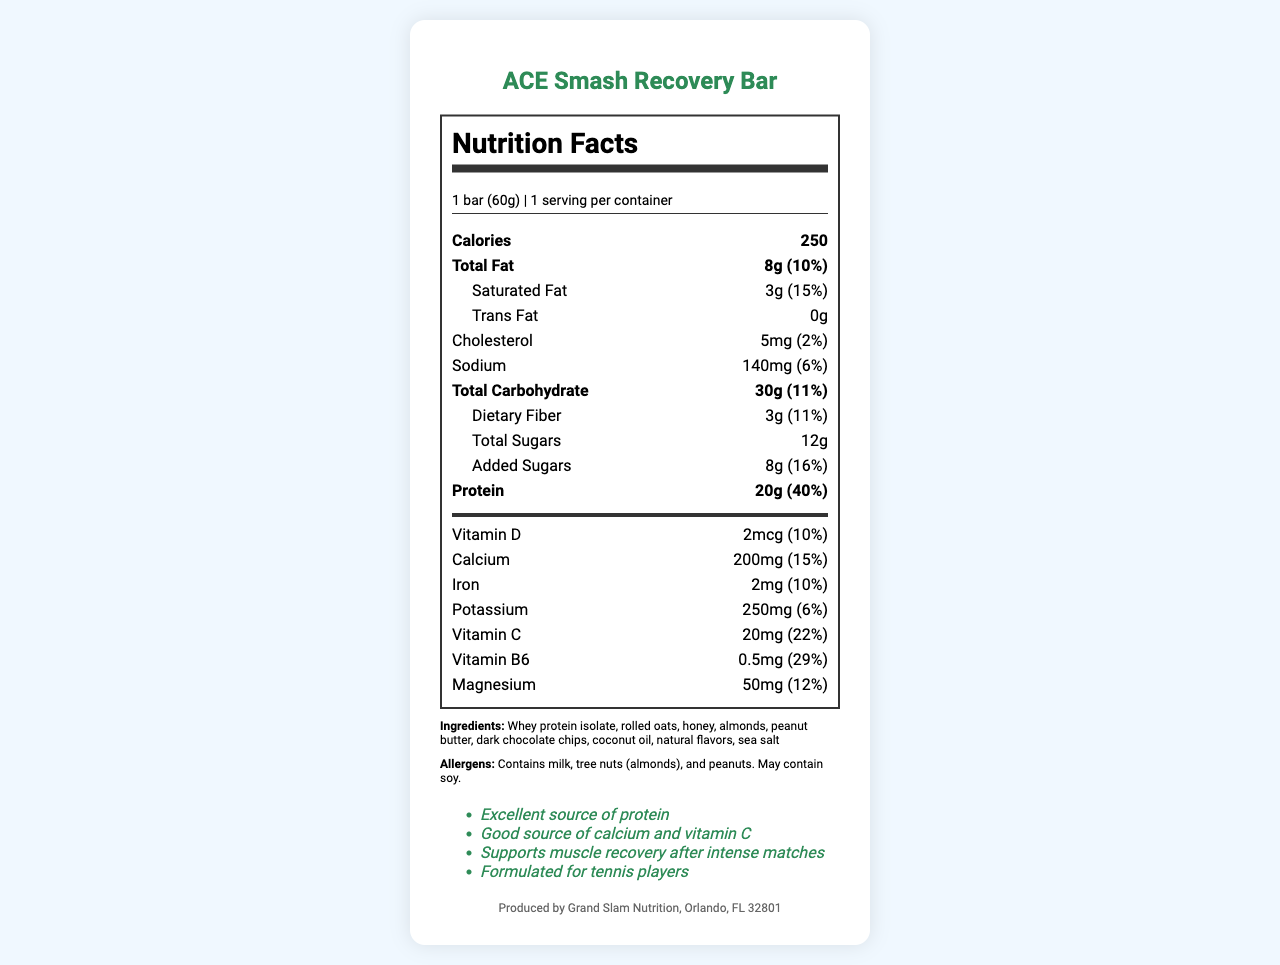what is the name of the product? The name of the product is clearly stated at the top of the document.
Answer: ACE Smash Recovery Bar how many grams of protein does this bar contain? The amount of protein is listed in the "Nutrition Facts" section under "Protein."
Answer: 20g what is the serving size? The serving size is mentioned in the "serving-info" section at the top of the nutrition label.
Answer: 1 bar (60g) which vitamins are included in the bar? The vitamins are listed in the "vitamins" subsection under the nutrition label.
Answer: Vitamin D, Calcium, Iron, Potassium, Vitamin C, Vitamin B6, Magnesium how many milligrams of calcium are there per serving? The amount of calcium is listed under the "vitamins" subsection.
Answer: 200mg how many calories does one bar provide? The number of calories is located in the "Nutrition Facts" section.
Answer: 250 what is the manufacturer information? The manufacturer information is displayed at the bottom of the document.
Answer: Produced by Grand Slam Nutrition, Orlando, FL 32801 how much total carbohydrate is in this bar? The amount of total carbohydrate is listed in the "Nutrition Facts" section.
Answer: 30g which allergens are present in this bar? The allergens are listed in a separate section following the ingredients.
Answer: Contains milk, tree nuts (almonds), and peanuts. May contain soy. how much added sugar does this bar have? The amount of added sugars is located within the carbohydrates section in the "Nutrition Facts" label.
Answer: 8g what is the serving size in grams? A. 50g B. 60g C. 70g The serving size is noted as "1 bar (60g)" in the serving info section.
Answer: B where is the product manufactured? A. New York, NY B. Los Angeles, CA C. Orlando, FL The manufacturer information indicates it is produced in Orlando, FL.
Answer: C does the product contain any dietary fiber? The dietary fiber content is listed under total carbohydrate as 3g.
Answer: Yes is this bar an excellent source of protein? One of the claim statements mentions that the bar is "an excellent source of protein."
Answer: Yes summarize the main idea of the document. The document features nutrition facts, ingredients, claim statements, and manufacturer information, highlighting the high protein content and vitamin-rich composition of the ACE Smash Recovery Bar.
Answer: The document provides nutritional information for the ACE Smash Recovery Bar, specifically designed for tennis players. It emphasizes high protein content (20g per bar) and contains various vitamins such as Vitamin D, C, and B6. It includes some allergens like milk, almonds, and peanuts. The product is manufactured by Grand Slam Nutrition in Orlando, FL. what is the manufacturing date of the product? The document does not provide any information about the manufacturing date of the product.
Answer: Cannot be determined 